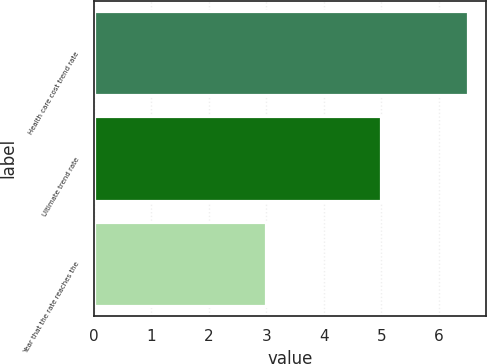<chart> <loc_0><loc_0><loc_500><loc_500><bar_chart><fcel>Health care cost trend rate<fcel>Ultimate trend rate<fcel>Year that the rate reaches the<nl><fcel>6.5<fcel>5<fcel>3<nl></chart> 